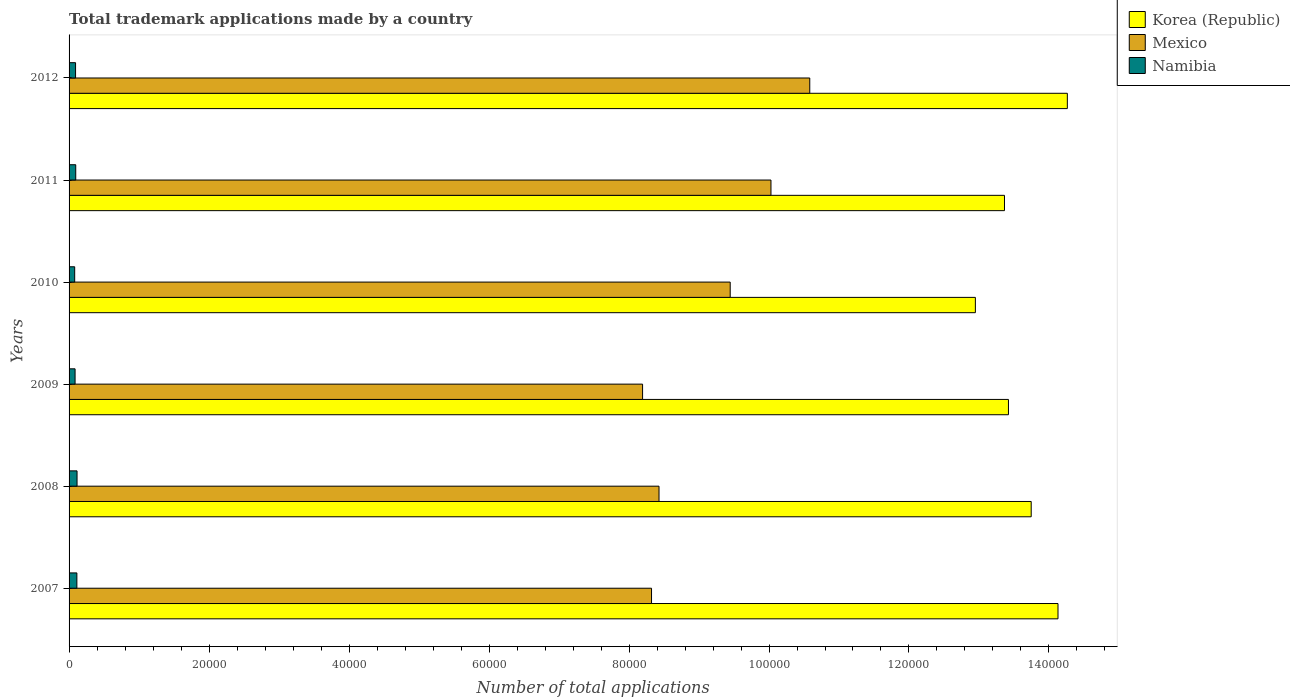How many groups of bars are there?
Ensure brevity in your answer.  6. Are the number of bars per tick equal to the number of legend labels?
Offer a very short reply. Yes. What is the label of the 1st group of bars from the top?
Keep it short and to the point. 2012. In how many cases, is the number of bars for a given year not equal to the number of legend labels?
Provide a succinct answer. 0. What is the number of applications made by in Mexico in 2009?
Make the answer very short. 8.19e+04. Across all years, what is the maximum number of applications made by in Mexico?
Give a very brief answer. 1.06e+05. Across all years, what is the minimum number of applications made by in Namibia?
Offer a very short reply. 802. In which year was the number of applications made by in Mexico minimum?
Keep it short and to the point. 2009. What is the total number of applications made by in Mexico in the graph?
Your answer should be compact. 5.50e+05. What is the difference between the number of applications made by in Namibia in 2007 and that in 2012?
Keep it short and to the point. 188. What is the difference between the number of applications made by in Namibia in 2010 and the number of applications made by in Mexico in 2008?
Offer a very short reply. -8.35e+04. What is the average number of applications made by in Korea (Republic) per year?
Offer a very short reply. 1.36e+05. In the year 2007, what is the difference between the number of applications made by in Korea (Republic) and number of applications made by in Mexico?
Your answer should be very brief. 5.81e+04. What is the ratio of the number of applications made by in Namibia in 2007 to that in 2012?
Provide a succinct answer. 1.2. Is the difference between the number of applications made by in Korea (Republic) in 2008 and 2012 greater than the difference between the number of applications made by in Mexico in 2008 and 2012?
Keep it short and to the point. Yes. What is the difference between the highest and the second highest number of applications made by in Mexico?
Your answer should be compact. 5544. What is the difference between the highest and the lowest number of applications made by in Korea (Republic)?
Your response must be concise. 1.31e+04. Is the sum of the number of applications made by in Mexico in 2008 and 2010 greater than the maximum number of applications made by in Korea (Republic) across all years?
Offer a terse response. Yes. What does the 3rd bar from the top in 2008 represents?
Provide a succinct answer. Korea (Republic). What does the 3rd bar from the bottom in 2010 represents?
Your answer should be very brief. Namibia. Is it the case that in every year, the sum of the number of applications made by in Namibia and number of applications made by in Mexico is greater than the number of applications made by in Korea (Republic)?
Keep it short and to the point. No. Does the graph contain any zero values?
Provide a succinct answer. No. Where does the legend appear in the graph?
Your response must be concise. Top right. How are the legend labels stacked?
Offer a very short reply. Vertical. What is the title of the graph?
Provide a succinct answer. Total trademark applications made by a country. What is the label or title of the X-axis?
Provide a succinct answer. Number of total applications. What is the label or title of the Y-axis?
Provide a succinct answer. Years. What is the Number of total applications in Korea (Republic) in 2007?
Your answer should be compact. 1.41e+05. What is the Number of total applications of Mexico in 2007?
Ensure brevity in your answer.  8.32e+04. What is the Number of total applications in Namibia in 2007?
Provide a short and direct response. 1116. What is the Number of total applications of Korea (Republic) in 2008?
Offer a terse response. 1.37e+05. What is the Number of total applications of Mexico in 2008?
Make the answer very short. 8.43e+04. What is the Number of total applications in Namibia in 2008?
Provide a short and direct response. 1139. What is the Number of total applications in Korea (Republic) in 2009?
Offer a terse response. 1.34e+05. What is the Number of total applications of Mexico in 2009?
Provide a short and direct response. 8.19e+04. What is the Number of total applications in Namibia in 2009?
Offer a terse response. 858. What is the Number of total applications of Korea (Republic) in 2010?
Keep it short and to the point. 1.29e+05. What is the Number of total applications of Mexico in 2010?
Offer a terse response. 9.45e+04. What is the Number of total applications in Namibia in 2010?
Ensure brevity in your answer.  802. What is the Number of total applications in Korea (Republic) in 2011?
Your answer should be compact. 1.34e+05. What is the Number of total applications of Mexico in 2011?
Ensure brevity in your answer.  1.00e+05. What is the Number of total applications in Namibia in 2011?
Make the answer very short. 951. What is the Number of total applications of Korea (Republic) in 2012?
Offer a terse response. 1.43e+05. What is the Number of total applications of Mexico in 2012?
Provide a succinct answer. 1.06e+05. What is the Number of total applications in Namibia in 2012?
Your response must be concise. 928. Across all years, what is the maximum Number of total applications of Korea (Republic)?
Provide a succinct answer. 1.43e+05. Across all years, what is the maximum Number of total applications of Mexico?
Make the answer very short. 1.06e+05. Across all years, what is the maximum Number of total applications of Namibia?
Make the answer very short. 1139. Across all years, what is the minimum Number of total applications of Korea (Republic)?
Make the answer very short. 1.29e+05. Across all years, what is the minimum Number of total applications in Mexico?
Give a very brief answer. 8.19e+04. Across all years, what is the minimum Number of total applications of Namibia?
Give a very brief answer. 802. What is the total Number of total applications in Korea (Republic) in the graph?
Make the answer very short. 8.19e+05. What is the total Number of total applications in Mexico in the graph?
Offer a very short reply. 5.50e+05. What is the total Number of total applications of Namibia in the graph?
Offer a very short reply. 5794. What is the difference between the Number of total applications in Korea (Republic) in 2007 and that in 2008?
Give a very brief answer. 3828. What is the difference between the Number of total applications in Mexico in 2007 and that in 2008?
Your answer should be compact. -1071. What is the difference between the Number of total applications in Korea (Republic) in 2007 and that in 2009?
Your response must be concise. 7078. What is the difference between the Number of total applications in Mexico in 2007 and that in 2009?
Keep it short and to the point. 1279. What is the difference between the Number of total applications of Namibia in 2007 and that in 2009?
Your answer should be very brief. 258. What is the difference between the Number of total applications in Korea (Republic) in 2007 and that in 2010?
Provide a succinct answer. 1.18e+04. What is the difference between the Number of total applications in Mexico in 2007 and that in 2010?
Keep it short and to the point. -1.12e+04. What is the difference between the Number of total applications in Namibia in 2007 and that in 2010?
Keep it short and to the point. 314. What is the difference between the Number of total applications of Korea (Republic) in 2007 and that in 2011?
Provide a short and direct response. 7644. What is the difference between the Number of total applications in Mexico in 2007 and that in 2011?
Your answer should be very brief. -1.71e+04. What is the difference between the Number of total applications of Namibia in 2007 and that in 2011?
Ensure brevity in your answer.  165. What is the difference between the Number of total applications in Korea (Republic) in 2007 and that in 2012?
Give a very brief answer. -1336. What is the difference between the Number of total applications in Mexico in 2007 and that in 2012?
Your response must be concise. -2.26e+04. What is the difference between the Number of total applications of Namibia in 2007 and that in 2012?
Your response must be concise. 188. What is the difference between the Number of total applications of Korea (Republic) in 2008 and that in 2009?
Your answer should be very brief. 3250. What is the difference between the Number of total applications in Mexico in 2008 and that in 2009?
Offer a very short reply. 2350. What is the difference between the Number of total applications in Namibia in 2008 and that in 2009?
Make the answer very short. 281. What is the difference between the Number of total applications of Korea (Republic) in 2008 and that in 2010?
Provide a succinct answer. 7975. What is the difference between the Number of total applications in Mexico in 2008 and that in 2010?
Give a very brief answer. -1.02e+04. What is the difference between the Number of total applications in Namibia in 2008 and that in 2010?
Make the answer very short. 337. What is the difference between the Number of total applications of Korea (Republic) in 2008 and that in 2011?
Your response must be concise. 3816. What is the difference between the Number of total applications of Mexico in 2008 and that in 2011?
Offer a very short reply. -1.60e+04. What is the difference between the Number of total applications in Namibia in 2008 and that in 2011?
Your response must be concise. 188. What is the difference between the Number of total applications of Korea (Republic) in 2008 and that in 2012?
Provide a short and direct response. -5164. What is the difference between the Number of total applications of Mexico in 2008 and that in 2012?
Keep it short and to the point. -2.15e+04. What is the difference between the Number of total applications of Namibia in 2008 and that in 2012?
Ensure brevity in your answer.  211. What is the difference between the Number of total applications in Korea (Republic) in 2009 and that in 2010?
Provide a short and direct response. 4725. What is the difference between the Number of total applications in Mexico in 2009 and that in 2010?
Offer a very short reply. -1.25e+04. What is the difference between the Number of total applications of Namibia in 2009 and that in 2010?
Give a very brief answer. 56. What is the difference between the Number of total applications in Korea (Republic) in 2009 and that in 2011?
Keep it short and to the point. 566. What is the difference between the Number of total applications in Mexico in 2009 and that in 2011?
Give a very brief answer. -1.83e+04. What is the difference between the Number of total applications in Namibia in 2009 and that in 2011?
Offer a very short reply. -93. What is the difference between the Number of total applications in Korea (Republic) in 2009 and that in 2012?
Your answer should be very brief. -8414. What is the difference between the Number of total applications in Mexico in 2009 and that in 2012?
Your response must be concise. -2.39e+04. What is the difference between the Number of total applications in Namibia in 2009 and that in 2012?
Keep it short and to the point. -70. What is the difference between the Number of total applications of Korea (Republic) in 2010 and that in 2011?
Offer a terse response. -4159. What is the difference between the Number of total applications in Mexico in 2010 and that in 2011?
Provide a succinct answer. -5824. What is the difference between the Number of total applications in Namibia in 2010 and that in 2011?
Provide a succinct answer. -149. What is the difference between the Number of total applications of Korea (Republic) in 2010 and that in 2012?
Provide a succinct answer. -1.31e+04. What is the difference between the Number of total applications of Mexico in 2010 and that in 2012?
Offer a very short reply. -1.14e+04. What is the difference between the Number of total applications of Namibia in 2010 and that in 2012?
Your answer should be compact. -126. What is the difference between the Number of total applications of Korea (Republic) in 2011 and that in 2012?
Your answer should be very brief. -8980. What is the difference between the Number of total applications in Mexico in 2011 and that in 2012?
Provide a short and direct response. -5544. What is the difference between the Number of total applications of Korea (Republic) in 2007 and the Number of total applications of Mexico in 2008?
Keep it short and to the point. 5.70e+04. What is the difference between the Number of total applications of Korea (Republic) in 2007 and the Number of total applications of Namibia in 2008?
Provide a succinct answer. 1.40e+05. What is the difference between the Number of total applications of Mexico in 2007 and the Number of total applications of Namibia in 2008?
Provide a short and direct response. 8.21e+04. What is the difference between the Number of total applications of Korea (Republic) in 2007 and the Number of total applications of Mexico in 2009?
Give a very brief answer. 5.94e+04. What is the difference between the Number of total applications of Korea (Republic) in 2007 and the Number of total applications of Namibia in 2009?
Offer a terse response. 1.40e+05. What is the difference between the Number of total applications in Mexico in 2007 and the Number of total applications in Namibia in 2009?
Ensure brevity in your answer.  8.24e+04. What is the difference between the Number of total applications in Korea (Republic) in 2007 and the Number of total applications in Mexico in 2010?
Provide a succinct answer. 4.68e+04. What is the difference between the Number of total applications in Korea (Republic) in 2007 and the Number of total applications in Namibia in 2010?
Provide a succinct answer. 1.40e+05. What is the difference between the Number of total applications of Mexico in 2007 and the Number of total applications of Namibia in 2010?
Your response must be concise. 8.24e+04. What is the difference between the Number of total applications of Korea (Republic) in 2007 and the Number of total applications of Mexico in 2011?
Your answer should be compact. 4.10e+04. What is the difference between the Number of total applications of Korea (Republic) in 2007 and the Number of total applications of Namibia in 2011?
Offer a very short reply. 1.40e+05. What is the difference between the Number of total applications in Mexico in 2007 and the Number of total applications in Namibia in 2011?
Give a very brief answer. 8.23e+04. What is the difference between the Number of total applications in Korea (Republic) in 2007 and the Number of total applications in Mexico in 2012?
Provide a short and direct response. 3.55e+04. What is the difference between the Number of total applications of Korea (Republic) in 2007 and the Number of total applications of Namibia in 2012?
Offer a very short reply. 1.40e+05. What is the difference between the Number of total applications in Mexico in 2007 and the Number of total applications in Namibia in 2012?
Provide a short and direct response. 8.23e+04. What is the difference between the Number of total applications in Korea (Republic) in 2008 and the Number of total applications in Mexico in 2009?
Offer a terse response. 5.55e+04. What is the difference between the Number of total applications of Korea (Republic) in 2008 and the Number of total applications of Namibia in 2009?
Ensure brevity in your answer.  1.37e+05. What is the difference between the Number of total applications of Mexico in 2008 and the Number of total applications of Namibia in 2009?
Your answer should be compact. 8.34e+04. What is the difference between the Number of total applications in Korea (Republic) in 2008 and the Number of total applications in Mexico in 2010?
Offer a very short reply. 4.30e+04. What is the difference between the Number of total applications in Korea (Republic) in 2008 and the Number of total applications in Namibia in 2010?
Ensure brevity in your answer.  1.37e+05. What is the difference between the Number of total applications in Mexico in 2008 and the Number of total applications in Namibia in 2010?
Ensure brevity in your answer.  8.35e+04. What is the difference between the Number of total applications in Korea (Republic) in 2008 and the Number of total applications in Mexico in 2011?
Keep it short and to the point. 3.72e+04. What is the difference between the Number of total applications in Korea (Republic) in 2008 and the Number of total applications in Namibia in 2011?
Give a very brief answer. 1.37e+05. What is the difference between the Number of total applications of Mexico in 2008 and the Number of total applications of Namibia in 2011?
Your answer should be compact. 8.33e+04. What is the difference between the Number of total applications in Korea (Republic) in 2008 and the Number of total applications in Mexico in 2012?
Provide a succinct answer. 3.16e+04. What is the difference between the Number of total applications in Korea (Republic) in 2008 and the Number of total applications in Namibia in 2012?
Offer a very short reply. 1.37e+05. What is the difference between the Number of total applications in Mexico in 2008 and the Number of total applications in Namibia in 2012?
Keep it short and to the point. 8.34e+04. What is the difference between the Number of total applications of Korea (Republic) in 2009 and the Number of total applications of Mexico in 2010?
Make the answer very short. 3.98e+04. What is the difference between the Number of total applications of Korea (Republic) in 2009 and the Number of total applications of Namibia in 2010?
Offer a terse response. 1.33e+05. What is the difference between the Number of total applications of Mexico in 2009 and the Number of total applications of Namibia in 2010?
Provide a short and direct response. 8.11e+04. What is the difference between the Number of total applications in Korea (Republic) in 2009 and the Number of total applications in Mexico in 2011?
Your response must be concise. 3.39e+04. What is the difference between the Number of total applications of Korea (Republic) in 2009 and the Number of total applications of Namibia in 2011?
Provide a short and direct response. 1.33e+05. What is the difference between the Number of total applications in Mexico in 2009 and the Number of total applications in Namibia in 2011?
Give a very brief answer. 8.10e+04. What is the difference between the Number of total applications of Korea (Republic) in 2009 and the Number of total applications of Mexico in 2012?
Your response must be concise. 2.84e+04. What is the difference between the Number of total applications of Korea (Republic) in 2009 and the Number of total applications of Namibia in 2012?
Your answer should be compact. 1.33e+05. What is the difference between the Number of total applications of Mexico in 2009 and the Number of total applications of Namibia in 2012?
Offer a terse response. 8.10e+04. What is the difference between the Number of total applications in Korea (Republic) in 2010 and the Number of total applications in Mexico in 2011?
Offer a terse response. 2.92e+04. What is the difference between the Number of total applications in Korea (Republic) in 2010 and the Number of total applications in Namibia in 2011?
Ensure brevity in your answer.  1.29e+05. What is the difference between the Number of total applications in Mexico in 2010 and the Number of total applications in Namibia in 2011?
Offer a very short reply. 9.35e+04. What is the difference between the Number of total applications of Korea (Republic) in 2010 and the Number of total applications of Mexico in 2012?
Your answer should be compact. 2.37e+04. What is the difference between the Number of total applications in Korea (Republic) in 2010 and the Number of total applications in Namibia in 2012?
Your answer should be very brief. 1.29e+05. What is the difference between the Number of total applications in Mexico in 2010 and the Number of total applications in Namibia in 2012?
Give a very brief answer. 9.35e+04. What is the difference between the Number of total applications of Korea (Republic) in 2011 and the Number of total applications of Mexico in 2012?
Offer a very short reply. 2.78e+04. What is the difference between the Number of total applications in Korea (Republic) in 2011 and the Number of total applications in Namibia in 2012?
Ensure brevity in your answer.  1.33e+05. What is the difference between the Number of total applications in Mexico in 2011 and the Number of total applications in Namibia in 2012?
Your answer should be very brief. 9.94e+04. What is the average Number of total applications in Korea (Republic) per year?
Provide a short and direct response. 1.36e+05. What is the average Number of total applications of Mexico per year?
Ensure brevity in your answer.  9.17e+04. What is the average Number of total applications in Namibia per year?
Your answer should be compact. 965.67. In the year 2007, what is the difference between the Number of total applications of Korea (Republic) and Number of total applications of Mexico?
Ensure brevity in your answer.  5.81e+04. In the year 2007, what is the difference between the Number of total applications in Korea (Republic) and Number of total applications in Namibia?
Your answer should be compact. 1.40e+05. In the year 2007, what is the difference between the Number of total applications in Mexico and Number of total applications in Namibia?
Your response must be concise. 8.21e+04. In the year 2008, what is the difference between the Number of total applications in Korea (Republic) and Number of total applications in Mexico?
Your answer should be compact. 5.32e+04. In the year 2008, what is the difference between the Number of total applications in Korea (Republic) and Number of total applications in Namibia?
Your response must be concise. 1.36e+05. In the year 2008, what is the difference between the Number of total applications of Mexico and Number of total applications of Namibia?
Offer a very short reply. 8.31e+04. In the year 2009, what is the difference between the Number of total applications in Korea (Republic) and Number of total applications in Mexico?
Provide a short and direct response. 5.23e+04. In the year 2009, what is the difference between the Number of total applications in Korea (Republic) and Number of total applications in Namibia?
Offer a very short reply. 1.33e+05. In the year 2009, what is the difference between the Number of total applications of Mexico and Number of total applications of Namibia?
Make the answer very short. 8.11e+04. In the year 2010, what is the difference between the Number of total applications of Korea (Republic) and Number of total applications of Mexico?
Your answer should be compact. 3.50e+04. In the year 2010, what is the difference between the Number of total applications of Korea (Republic) and Number of total applications of Namibia?
Make the answer very short. 1.29e+05. In the year 2010, what is the difference between the Number of total applications of Mexico and Number of total applications of Namibia?
Provide a short and direct response. 9.37e+04. In the year 2011, what is the difference between the Number of total applications in Korea (Republic) and Number of total applications in Mexico?
Offer a very short reply. 3.34e+04. In the year 2011, what is the difference between the Number of total applications of Korea (Republic) and Number of total applications of Namibia?
Give a very brief answer. 1.33e+05. In the year 2011, what is the difference between the Number of total applications of Mexico and Number of total applications of Namibia?
Give a very brief answer. 9.93e+04. In the year 2012, what is the difference between the Number of total applications of Korea (Republic) and Number of total applications of Mexico?
Your answer should be compact. 3.68e+04. In the year 2012, what is the difference between the Number of total applications in Korea (Republic) and Number of total applications in Namibia?
Offer a terse response. 1.42e+05. In the year 2012, what is the difference between the Number of total applications of Mexico and Number of total applications of Namibia?
Your answer should be very brief. 1.05e+05. What is the ratio of the Number of total applications in Korea (Republic) in 2007 to that in 2008?
Ensure brevity in your answer.  1.03. What is the ratio of the Number of total applications in Mexico in 2007 to that in 2008?
Your response must be concise. 0.99. What is the ratio of the Number of total applications in Namibia in 2007 to that in 2008?
Offer a very short reply. 0.98. What is the ratio of the Number of total applications of Korea (Republic) in 2007 to that in 2009?
Provide a succinct answer. 1.05. What is the ratio of the Number of total applications in Mexico in 2007 to that in 2009?
Your response must be concise. 1.02. What is the ratio of the Number of total applications of Namibia in 2007 to that in 2009?
Give a very brief answer. 1.3. What is the ratio of the Number of total applications of Korea (Republic) in 2007 to that in 2010?
Give a very brief answer. 1.09. What is the ratio of the Number of total applications in Mexico in 2007 to that in 2010?
Your answer should be compact. 0.88. What is the ratio of the Number of total applications of Namibia in 2007 to that in 2010?
Offer a very short reply. 1.39. What is the ratio of the Number of total applications of Korea (Republic) in 2007 to that in 2011?
Provide a succinct answer. 1.06. What is the ratio of the Number of total applications of Mexico in 2007 to that in 2011?
Provide a succinct answer. 0.83. What is the ratio of the Number of total applications in Namibia in 2007 to that in 2011?
Offer a terse response. 1.17. What is the ratio of the Number of total applications in Korea (Republic) in 2007 to that in 2012?
Keep it short and to the point. 0.99. What is the ratio of the Number of total applications of Mexico in 2007 to that in 2012?
Your response must be concise. 0.79. What is the ratio of the Number of total applications of Namibia in 2007 to that in 2012?
Make the answer very short. 1.2. What is the ratio of the Number of total applications in Korea (Republic) in 2008 to that in 2009?
Your answer should be very brief. 1.02. What is the ratio of the Number of total applications of Mexico in 2008 to that in 2009?
Your answer should be very brief. 1.03. What is the ratio of the Number of total applications of Namibia in 2008 to that in 2009?
Your response must be concise. 1.33. What is the ratio of the Number of total applications of Korea (Republic) in 2008 to that in 2010?
Keep it short and to the point. 1.06. What is the ratio of the Number of total applications of Mexico in 2008 to that in 2010?
Ensure brevity in your answer.  0.89. What is the ratio of the Number of total applications of Namibia in 2008 to that in 2010?
Offer a very short reply. 1.42. What is the ratio of the Number of total applications of Korea (Republic) in 2008 to that in 2011?
Offer a very short reply. 1.03. What is the ratio of the Number of total applications of Mexico in 2008 to that in 2011?
Offer a terse response. 0.84. What is the ratio of the Number of total applications of Namibia in 2008 to that in 2011?
Offer a terse response. 1.2. What is the ratio of the Number of total applications in Korea (Republic) in 2008 to that in 2012?
Make the answer very short. 0.96. What is the ratio of the Number of total applications in Mexico in 2008 to that in 2012?
Provide a short and direct response. 0.8. What is the ratio of the Number of total applications in Namibia in 2008 to that in 2012?
Your answer should be very brief. 1.23. What is the ratio of the Number of total applications in Korea (Republic) in 2009 to that in 2010?
Ensure brevity in your answer.  1.04. What is the ratio of the Number of total applications of Mexico in 2009 to that in 2010?
Your answer should be very brief. 0.87. What is the ratio of the Number of total applications of Namibia in 2009 to that in 2010?
Offer a very short reply. 1.07. What is the ratio of the Number of total applications in Korea (Republic) in 2009 to that in 2011?
Your response must be concise. 1. What is the ratio of the Number of total applications of Mexico in 2009 to that in 2011?
Offer a terse response. 0.82. What is the ratio of the Number of total applications of Namibia in 2009 to that in 2011?
Make the answer very short. 0.9. What is the ratio of the Number of total applications of Korea (Republic) in 2009 to that in 2012?
Offer a very short reply. 0.94. What is the ratio of the Number of total applications in Mexico in 2009 to that in 2012?
Offer a terse response. 0.77. What is the ratio of the Number of total applications of Namibia in 2009 to that in 2012?
Offer a terse response. 0.92. What is the ratio of the Number of total applications of Korea (Republic) in 2010 to that in 2011?
Make the answer very short. 0.97. What is the ratio of the Number of total applications in Mexico in 2010 to that in 2011?
Ensure brevity in your answer.  0.94. What is the ratio of the Number of total applications in Namibia in 2010 to that in 2011?
Provide a succinct answer. 0.84. What is the ratio of the Number of total applications of Korea (Republic) in 2010 to that in 2012?
Your answer should be very brief. 0.91. What is the ratio of the Number of total applications of Mexico in 2010 to that in 2012?
Ensure brevity in your answer.  0.89. What is the ratio of the Number of total applications of Namibia in 2010 to that in 2012?
Your response must be concise. 0.86. What is the ratio of the Number of total applications in Korea (Republic) in 2011 to that in 2012?
Offer a terse response. 0.94. What is the ratio of the Number of total applications in Mexico in 2011 to that in 2012?
Ensure brevity in your answer.  0.95. What is the ratio of the Number of total applications of Namibia in 2011 to that in 2012?
Ensure brevity in your answer.  1.02. What is the difference between the highest and the second highest Number of total applications in Korea (Republic)?
Provide a short and direct response. 1336. What is the difference between the highest and the second highest Number of total applications in Mexico?
Provide a succinct answer. 5544. What is the difference between the highest and the lowest Number of total applications of Korea (Republic)?
Provide a short and direct response. 1.31e+04. What is the difference between the highest and the lowest Number of total applications in Mexico?
Provide a succinct answer. 2.39e+04. What is the difference between the highest and the lowest Number of total applications of Namibia?
Make the answer very short. 337. 